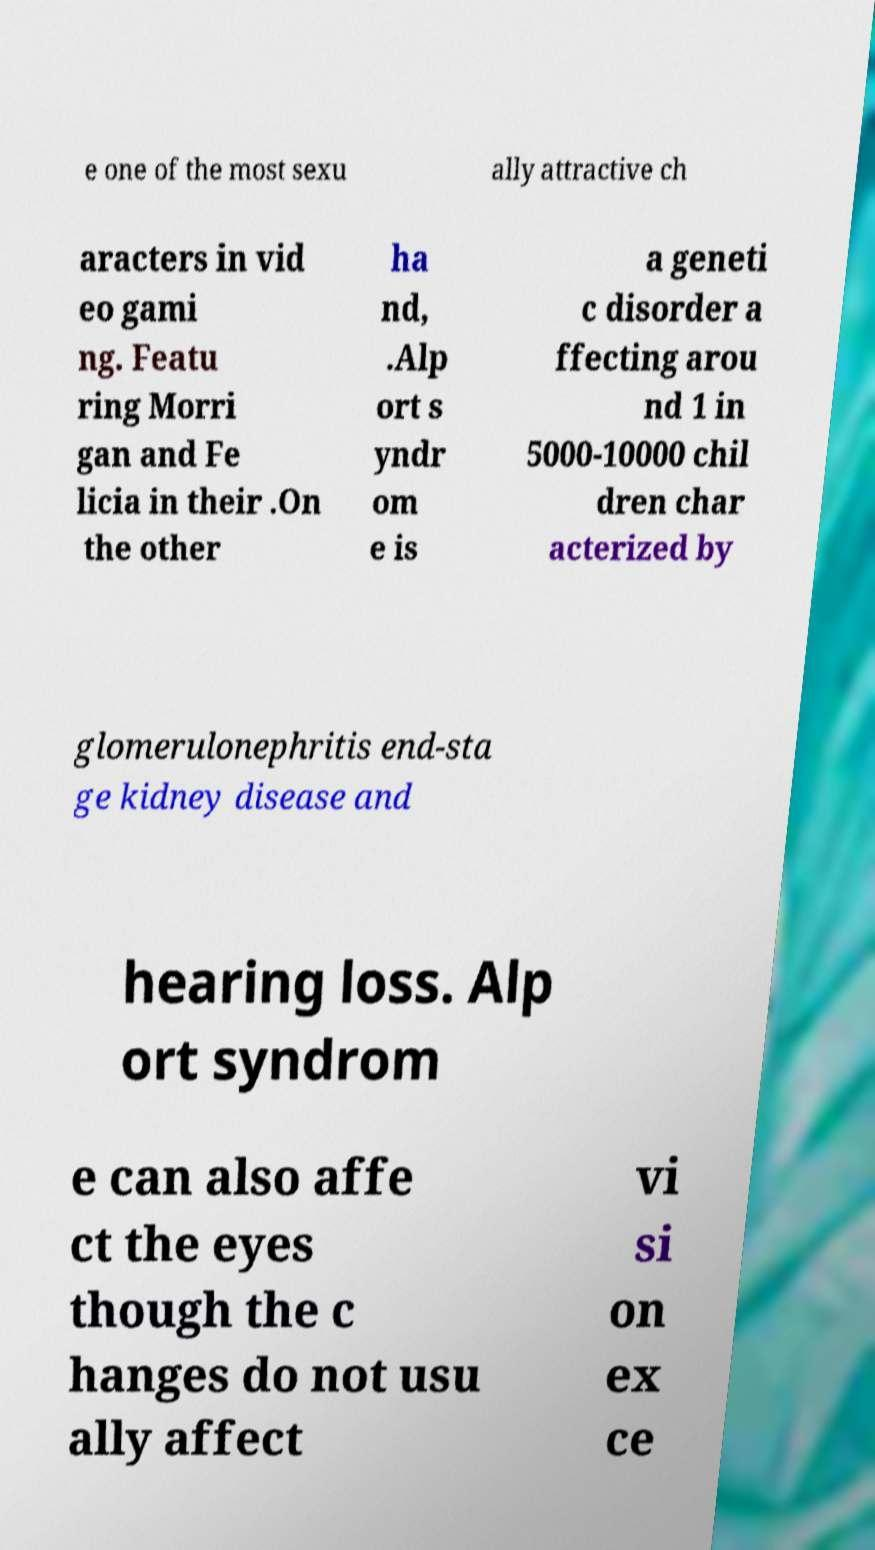Please read and relay the text visible in this image. What does it say? e one of the most sexu ally attractive ch aracters in vid eo gami ng. Featu ring Morri gan and Fe licia in their .On the other ha nd, .Alp ort s yndr om e is a geneti c disorder a ffecting arou nd 1 in 5000-10000 chil dren char acterized by glomerulonephritis end-sta ge kidney disease and hearing loss. Alp ort syndrom e can also affe ct the eyes though the c hanges do not usu ally affect vi si on ex ce 